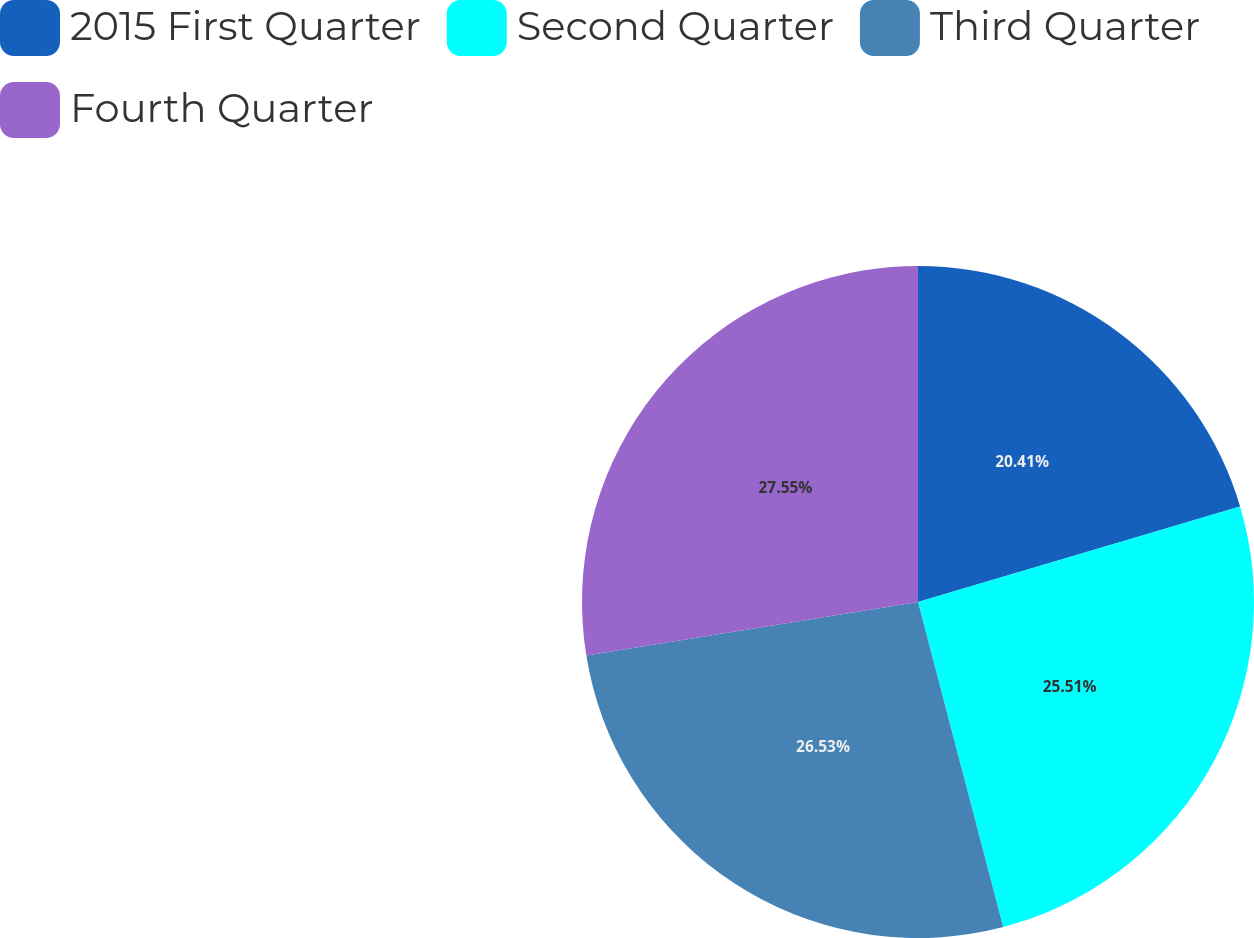<chart> <loc_0><loc_0><loc_500><loc_500><pie_chart><fcel>2015 First Quarter<fcel>Second Quarter<fcel>Third Quarter<fcel>Fourth Quarter<nl><fcel>20.41%<fcel>25.51%<fcel>26.53%<fcel>27.55%<nl></chart> 